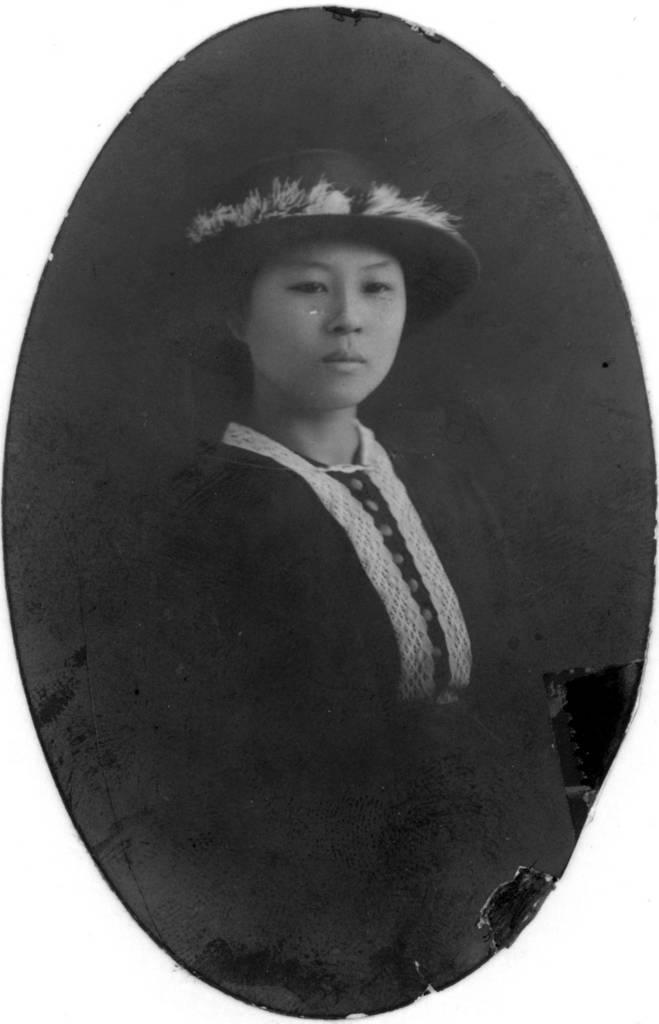Could you give a brief overview of what you see in this image? It looks like an old black and white picture of a woman. 